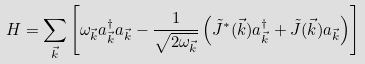<formula> <loc_0><loc_0><loc_500><loc_500>H = \sum _ { \vec { k } } \left [ \omega _ { \vec { k } } a ^ { \dagger } _ { \vec { k } } a _ { \vec { k } } - \frac { 1 } { \sqrt { 2 \omega _ { \vec { k } } } } \left ( \tilde { J } ^ { * } ( { \vec { k } } ) a ^ { \dagger } _ { \vec { k } } + \tilde { J } ( { \vec { k } } ) a _ { \vec { k } } \right ) \right ]</formula> 